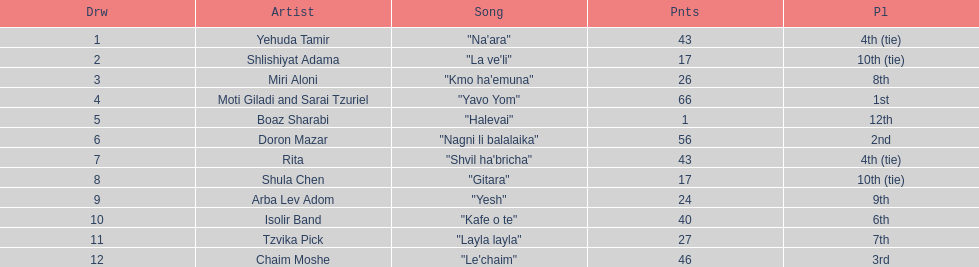Which artist had almost no points? Boaz Sharabi. 